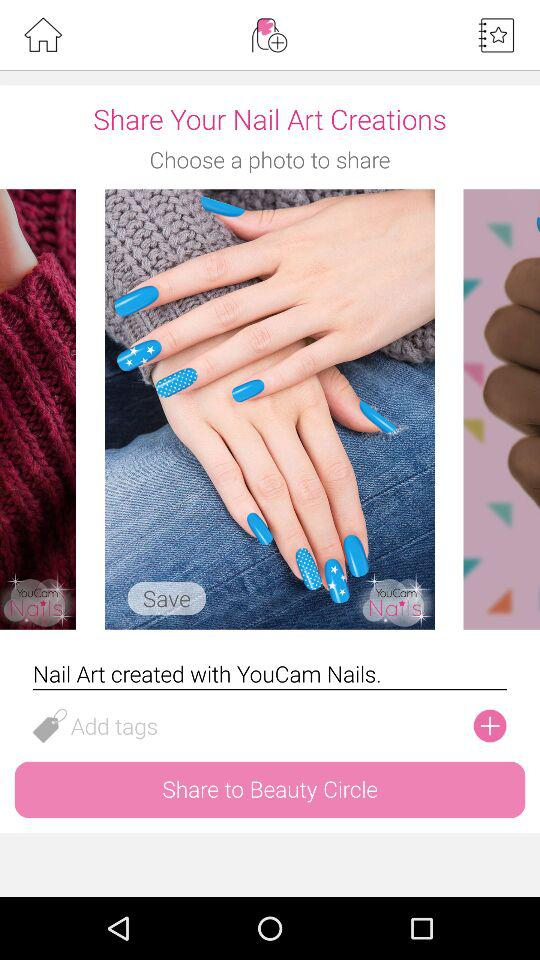Whom Can I Share My Created Nail Art With? You can share it with "Beauty Circle". 